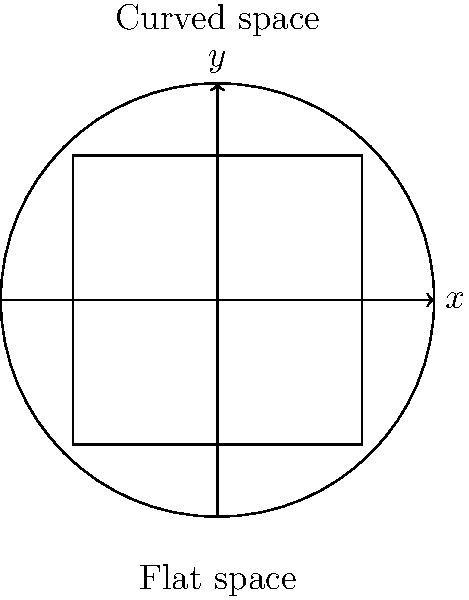In the context of cosmic inflation models, how does the curvature of space-time relate to non-Euclidean geometry, and what implications does this have for our understanding of the universe's expansion? Use the diagram to illustrate your answer, comparing the flat space (represented by the square) to the curved space (represented by the circle). 1. Non-Euclidean geometry and cosmic inflation:
   - Non-Euclidean geometry describes curved spaces, which is essential for understanding the curvature of space-time in cosmology.
   - Cosmic inflation models propose that the early universe underwent rapid expansion, affecting the geometry of space-time.

2. Curvature in the diagram:
   - The square represents flat (Euclidean) space, where parallel lines remain equidistant.
   - The circle represents curved (non-Euclidean) space, where the concept of parallel lines breaks down.

3. Relation to cosmic inflation:
   - Inflation theory suggests that the universe expanded exponentially in its early stages.
   - This rapid expansion would have "stretched" space-time, potentially flattening any initial curvature.

4. Implications for universe expansion:
   - In a flat universe (like the square), the expansion rate would be critical, meaning it would continue expanding indefinitely but at a decreasing rate.
   - In a positively curved universe (like the surface of a sphere), the expansion might eventually reverse, leading to a "Big Crunch."
   - In a negatively curved universe (like a saddle shape), the expansion would accelerate.

5. Observational evidence:
   - Current observations suggest that our universe is very close to flat, which aligns with predictions from cosmic inflation models.
   - The near-flatness of the universe is often cited as evidence supporting the inflationary paradigm.

6. Connection to non-Euclidean geometry:
   - General Relativity, which describes gravity as the curvature of space-time, uses non-Euclidean geometry.
   - The global geometry of the universe can be described using these non-Euclidean models, allowing us to predict and understand its large-scale structure and evolution.

In summary, non-Euclidean geometry provides the mathematical framework to describe the curvature of space-time in cosmic inflation models, helping us understand the universe's shape, expansion, and ultimate fate.
Answer: Non-Euclidean geometry describes space-time curvature in inflation models, explaining how rapid expansion affects universe shape and evolution, with current observations suggesting near-flatness consistent with inflationary theory. 